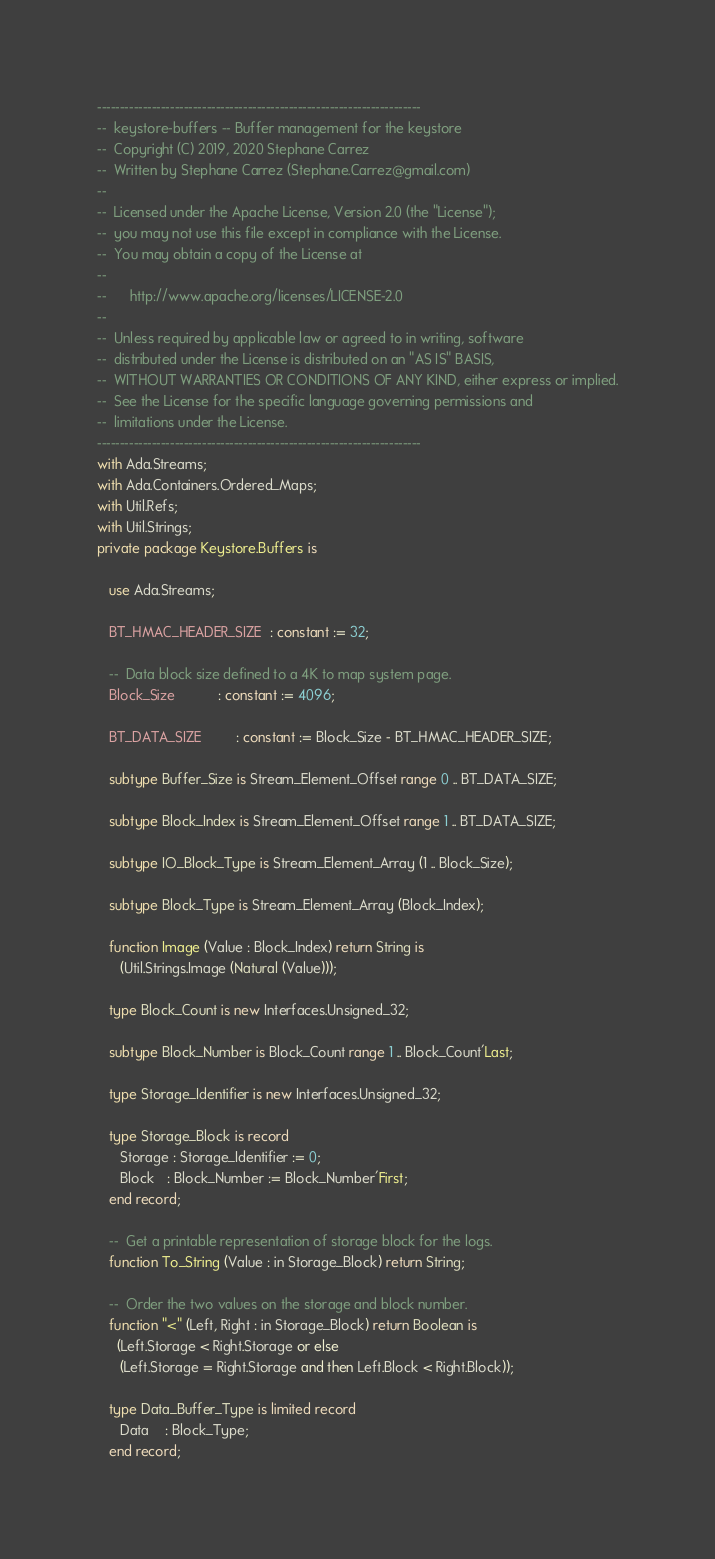<code> <loc_0><loc_0><loc_500><loc_500><_Ada_>-----------------------------------------------------------------------
--  keystore-buffers -- Buffer management for the keystore
--  Copyright (C) 2019, 2020 Stephane Carrez
--  Written by Stephane Carrez (Stephane.Carrez@gmail.com)
--
--  Licensed under the Apache License, Version 2.0 (the "License");
--  you may not use this file except in compliance with the License.
--  You may obtain a copy of the License at
--
--      http://www.apache.org/licenses/LICENSE-2.0
--
--  Unless required by applicable law or agreed to in writing, software
--  distributed under the License is distributed on an "AS IS" BASIS,
--  WITHOUT WARRANTIES OR CONDITIONS OF ANY KIND, either express or implied.
--  See the License for the specific language governing permissions and
--  limitations under the License.
-----------------------------------------------------------------------
with Ada.Streams;
with Ada.Containers.Ordered_Maps;
with Util.Refs;
with Util.Strings;
private package Keystore.Buffers is

   use Ada.Streams;

   BT_HMAC_HEADER_SIZE  : constant := 32;

   --  Data block size defined to a 4K to map system page.
   Block_Size           : constant := 4096;

   BT_DATA_SIZE         : constant := Block_Size - BT_HMAC_HEADER_SIZE;

   subtype Buffer_Size is Stream_Element_Offset range 0 .. BT_DATA_SIZE;

   subtype Block_Index is Stream_Element_Offset range 1 .. BT_DATA_SIZE;

   subtype IO_Block_Type is Stream_Element_Array (1 .. Block_Size);

   subtype Block_Type is Stream_Element_Array (Block_Index);

   function Image (Value : Block_Index) return String is
      (Util.Strings.Image (Natural (Value)));

   type Block_Count is new Interfaces.Unsigned_32;

   subtype Block_Number is Block_Count range 1 .. Block_Count'Last;

   type Storage_Identifier is new Interfaces.Unsigned_32;

   type Storage_Block is record
      Storage : Storage_Identifier := 0;
      Block   : Block_Number := Block_Number'First;
   end record;

   --  Get a printable representation of storage block for the logs.
   function To_String (Value : in Storage_Block) return String;

   --  Order the two values on the storage and block number.
   function "<" (Left, Right : in Storage_Block) return Boolean is
     (Left.Storage < Right.Storage or else
      (Left.Storage = Right.Storage and then Left.Block < Right.Block));

   type Data_Buffer_Type is limited record
      Data    : Block_Type;
   end record;
</code> 